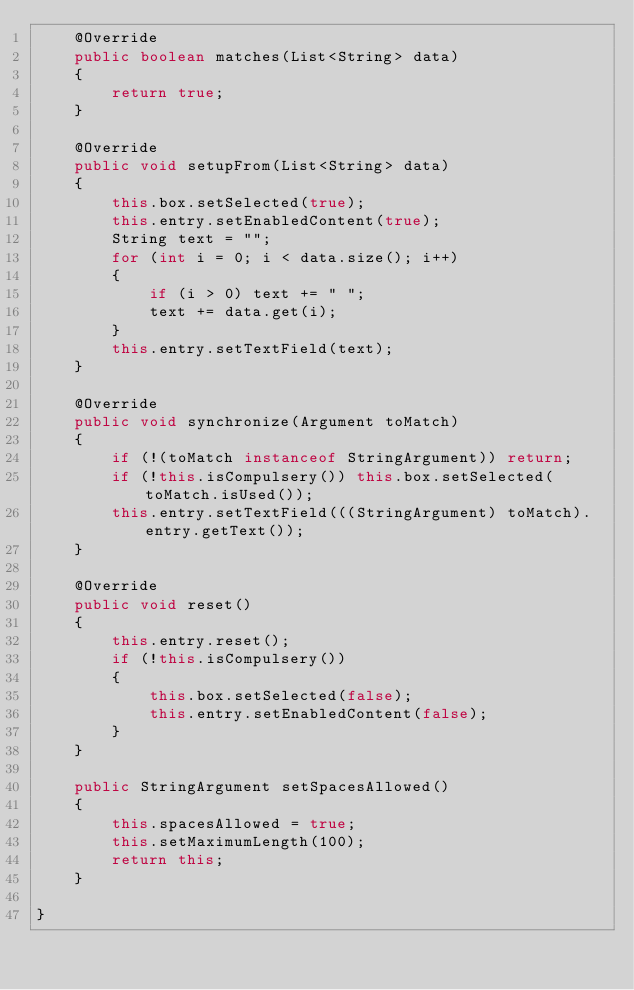<code> <loc_0><loc_0><loc_500><loc_500><_Java_>	@Override
	public boolean matches(List<String> data)
	{
		return true;
	}

	@Override
	public void setupFrom(List<String> data)
	{
		this.box.setSelected(true);
		this.entry.setEnabledContent(true);
		String text = "";
		for (int i = 0; i < data.size(); i++)
		{
			if (i > 0) text += " ";
			text += data.get(i);
		}
		this.entry.setTextField(text);
	}

	@Override
	public void synchronize(Argument toMatch)
	{
		if (!(toMatch instanceof StringArgument)) return;
		if (!this.isCompulsery()) this.box.setSelected(toMatch.isUsed());
		this.entry.setTextField(((StringArgument) toMatch).entry.getText());
	}

	@Override
	public void reset()
	{
		this.entry.reset();
		if (!this.isCompulsery())
		{
			this.box.setSelected(false);
			this.entry.setEnabledContent(false);
		}
	}

	public StringArgument setSpacesAllowed()
	{
		this.spacesAllowed = true;
		this.setMaximumLength(100);
		return this;
	}

}
</code> 